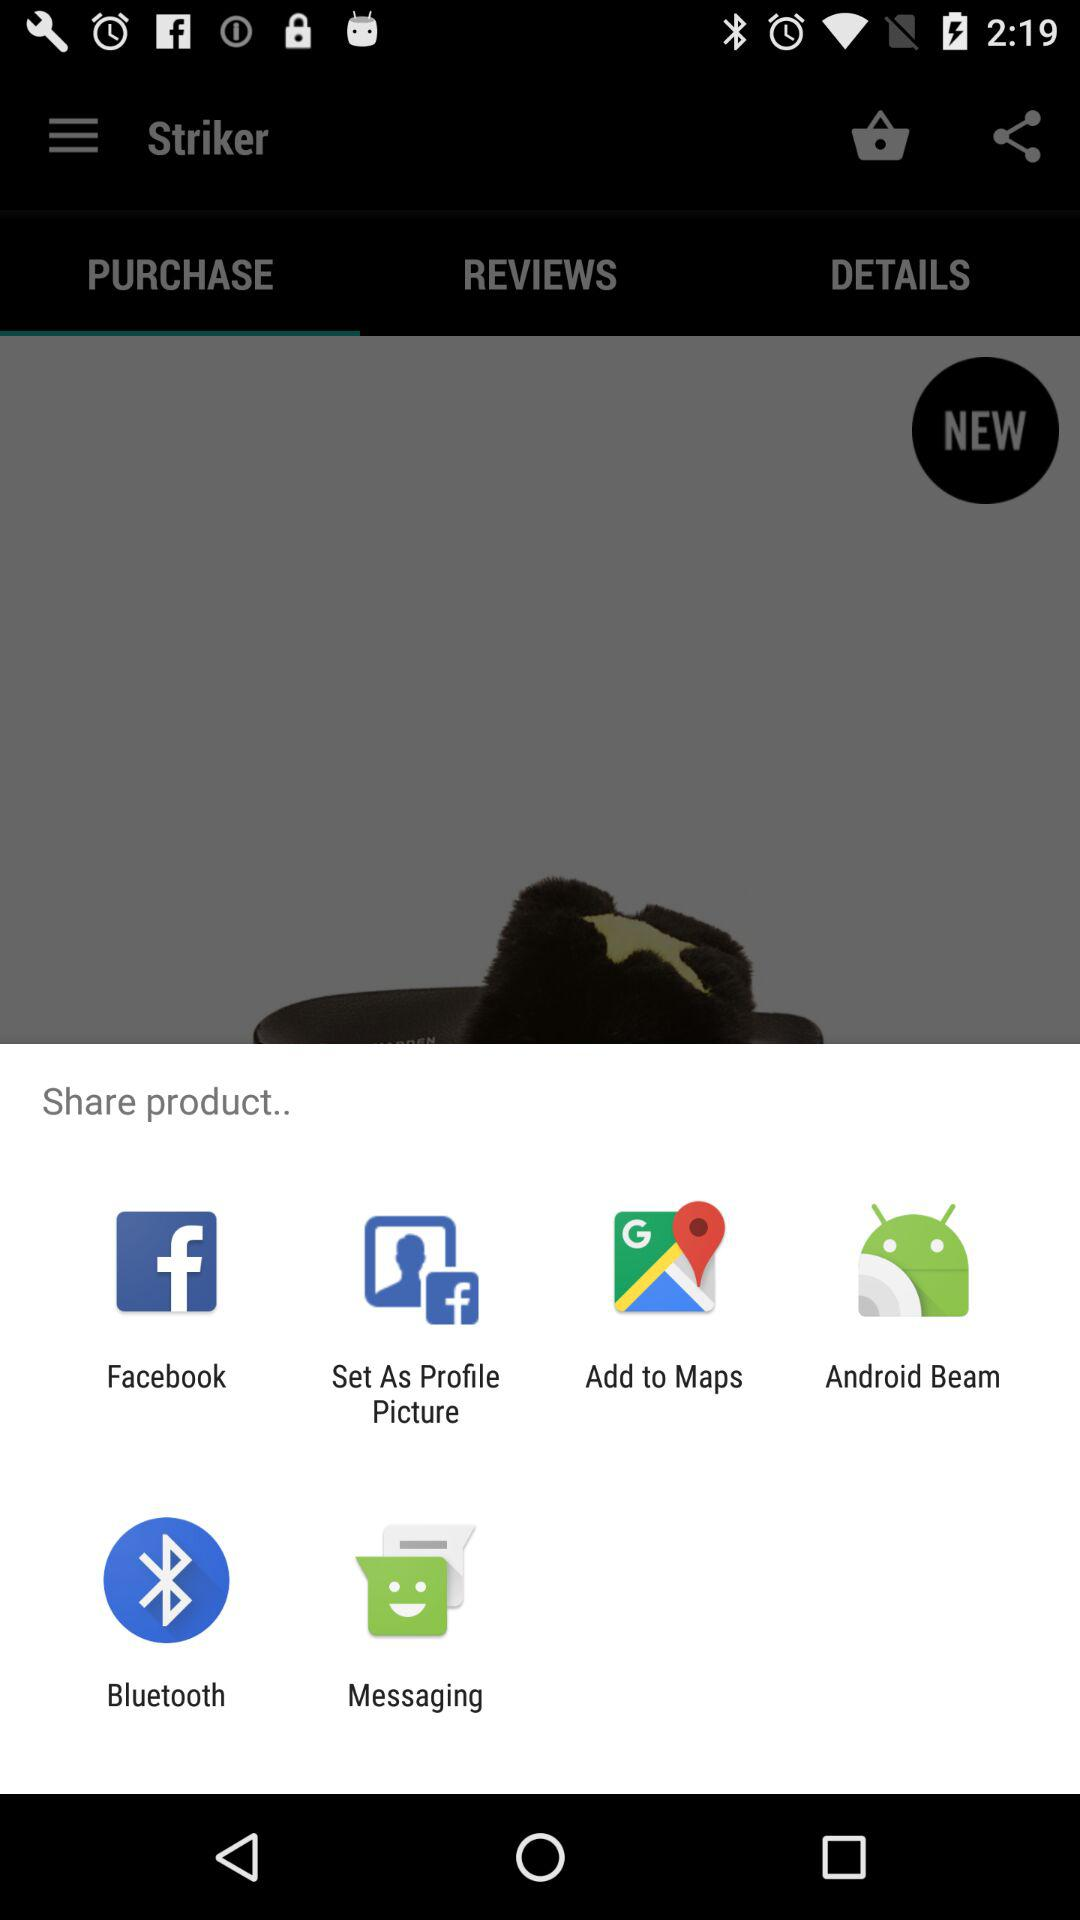Which options are given for sharing the product? The given options for sharing the product are "Facebook", "Set As Profile Picture", "Add to Maps", "Android Beam", "Bluetooth" and "Messaging". 